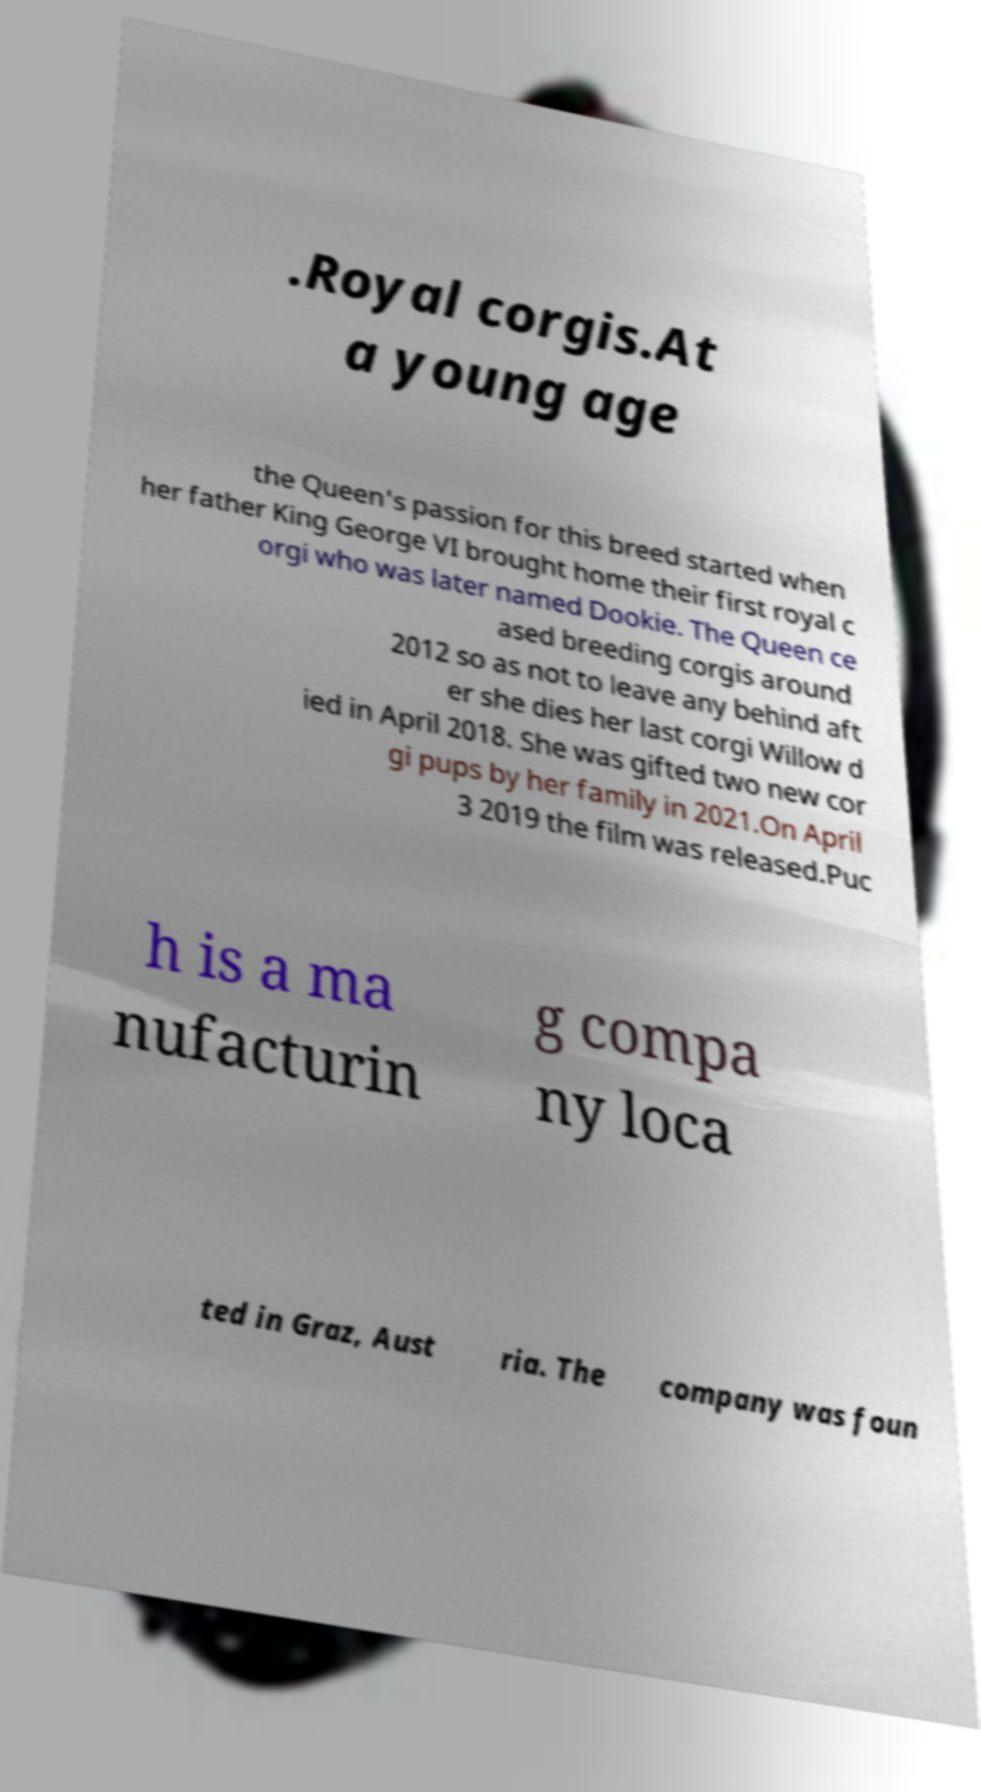For documentation purposes, I need the text within this image transcribed. Could you provide that? .Royal corgis.At a young age the Queen's passion for this breed started when her father King George VI brought home their first royal c orgi who was later named Dookie. The Queen ce ased breeding corgis around 2012 so as not to leave any behind aft er she dies her last corgi Willow d ied in April 2018. She was gifted two new cor gi pups by her family in 2021.On April 3 2019 the film was released.Puc h is a ma nufacturin g compa ny loca ted in Graz, Aust ria. The company was foun 